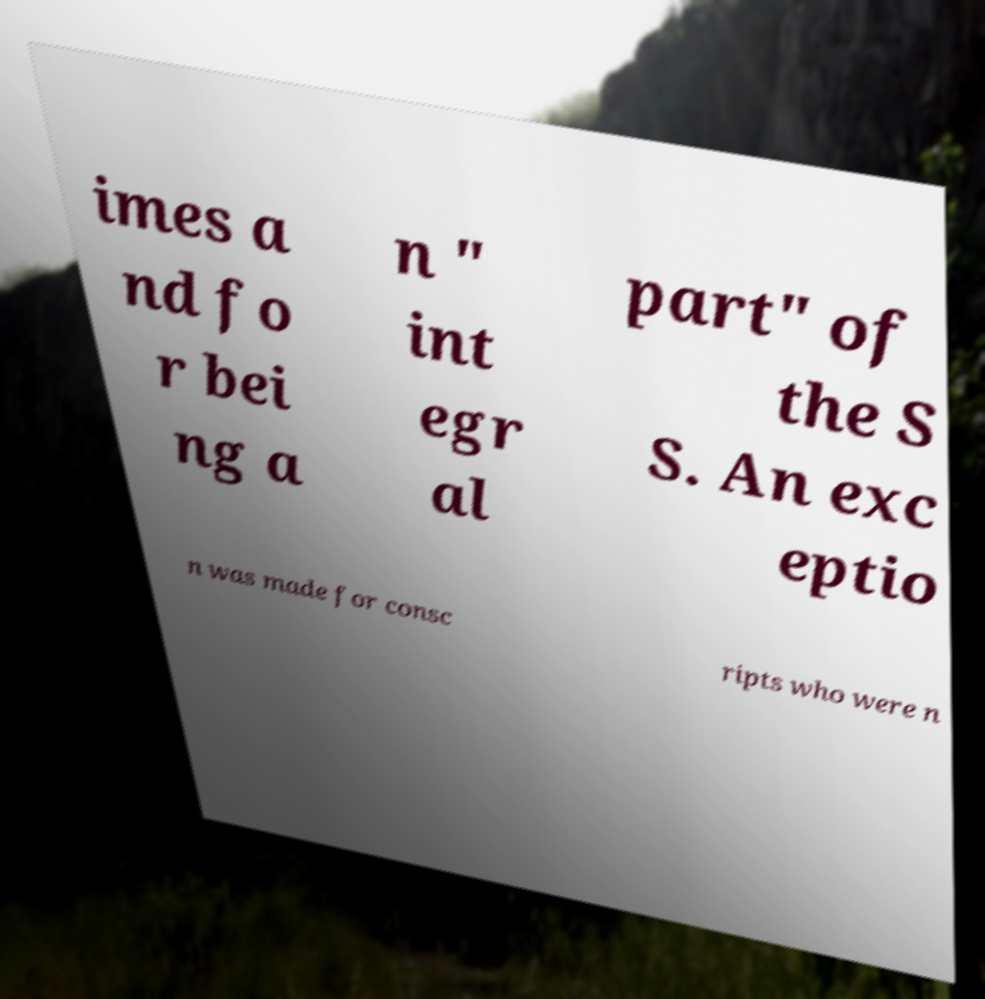Can you accurately transcribe the text from the provided image for me? imes a nd fo r bei ng a n " int egr al part" of the S S. An exc eptio n was made for consc ripts who were n 